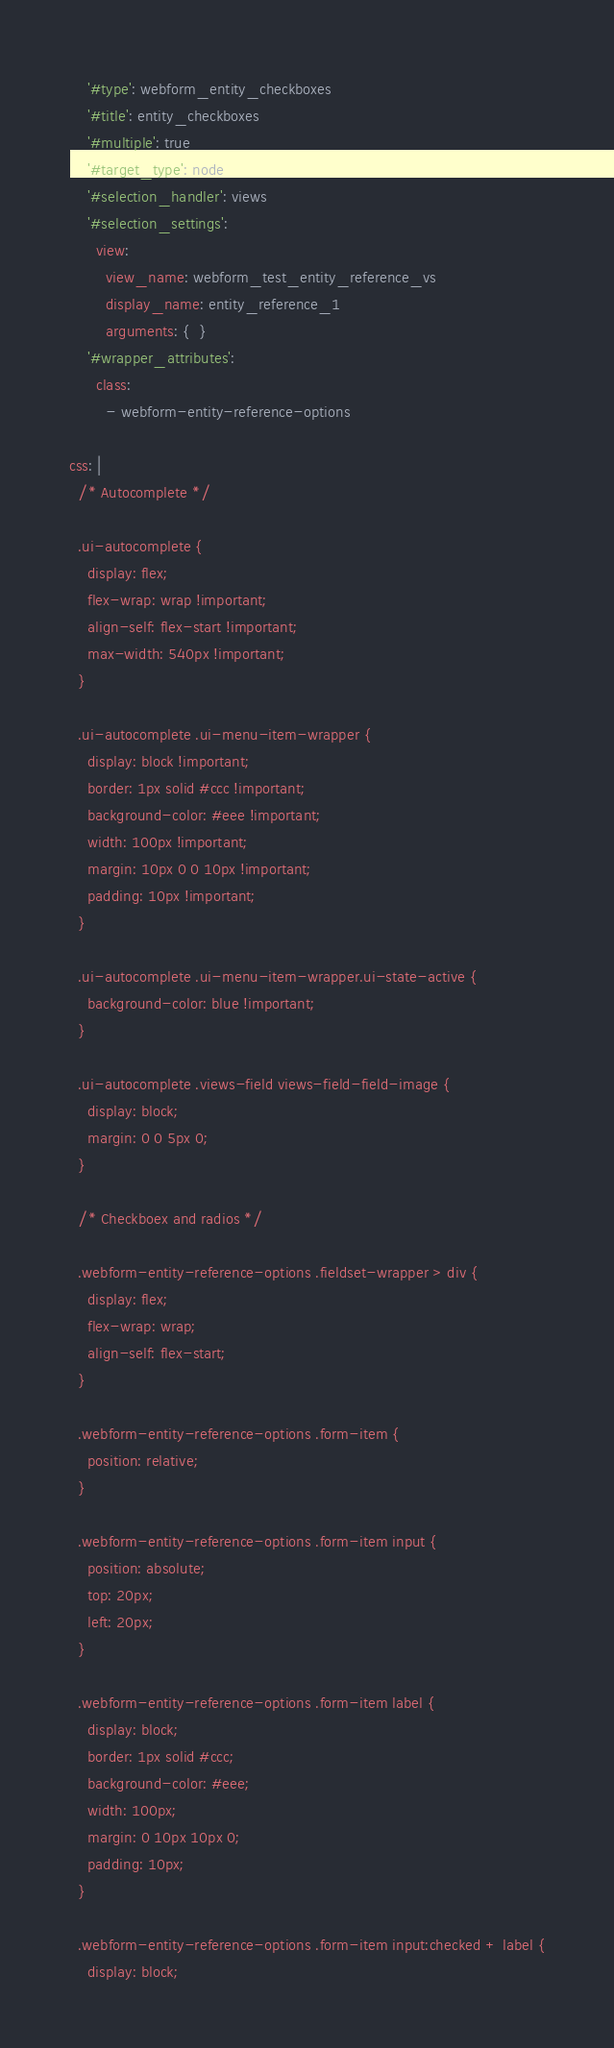<code> <loc_0><loc_0><loc_500><loc_500><_YAML_>    '#type': webform_entity_checkboxes
    '#title': entity_checkboxes
    '#multiple': true
    '#target_type': node
    '#selection_handler': views
    '#selection_settings':
      view:
        view_name: webform_test_entity_reference_vs
        display_name: entity_reference_1
        arguments: {  }
    '#wrapper_attributes':
      class:
        - webform-entity-reference-options
  
css: |
  /* Autocomplete */
  
  .ui-autocomplete {
    display: flex;
    flex-wrap: wrap !important;
    align-self: flex-start !important;
    max-width: 540px !important;
  }
  
  .ui-autocomplete .ui-menu-item-wrapper {
    display: block !important;
    border: 1px solid #ccc !important;
    background-color: #eee !important;
    width: 100px !important;
    margin: 10px 0 0 10px !important;
    padding: 10px !important;
  }
  
  .ui-autocomplete .ui-menu-item-wrapper.ui-state-active {
    background-color: blue !important;
  }
  
  .ui-autocomplete .views-field views-field-field-image {
    display: block;
    margin: 0 0 5px 0;
  }
  
  /* Checkboex and radios */
  
  .webform-entity-reference-options .fieldset-wrapper > div {
    display: flex;
    flex-wrap: wrap;
    align-self: flex-start;
  }
  
  .webform-entity-reference-options .form-item {
    position: relative;
  }
  
  .webform-entity-reference-options .form-item input {
    position: absolute;
    top: 20px;
    left: 20px; 
  }
  
  .webform-entity-reference-options .form-item label {
    display: block;
    border: 1px solid #ccc;
    background-color: #eee;
    width: 100px;
    margin: 0 10px 10px 0;  
    padding: 10px;  
  }
  
  .webform-entity-reference-options .form-item input:checked + label {
    display: block;</code> 